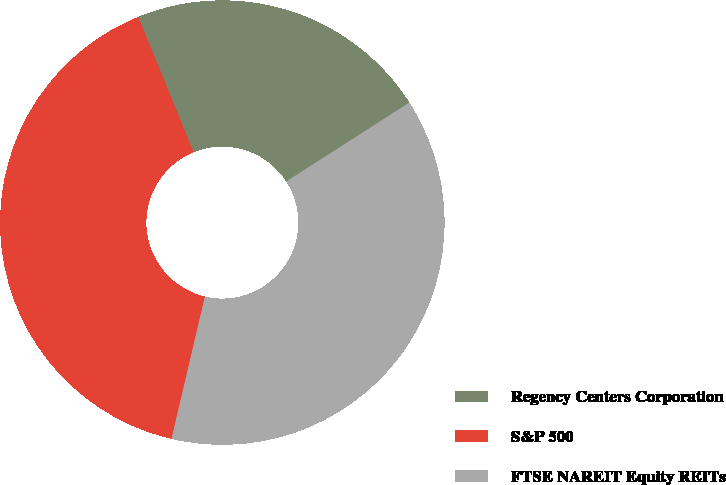Convert chart to OTSL. <chart><loc_0><loc_0><loc_500><loc_500><pie_chart><fcel>Regency Centers Corporation<fcel>S&P 500<fcel>FTSE NAREIT Equity REITs<nl><fcel>22.1%<fcel>40.15%<fcel>37.75%<nl></chart> 